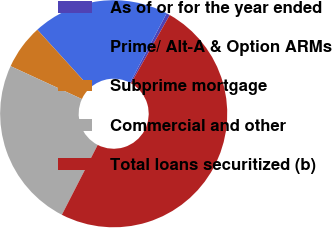Convert chart. <chart><loc_0><loc_0><loc_500><loc_500><pie_chart><fcel>As of or for the year ended<fcel>Prime/ Alt-A & Option ARMs<fcel>Subprime mortgage<fcel>Commercial and other<fcel>Total loans securitized (b)<nl><fcel>0.5%<fcel>19.46%<fcel>6.38%<fcel>24.34%<fcel>49.32%<nl></chart> 